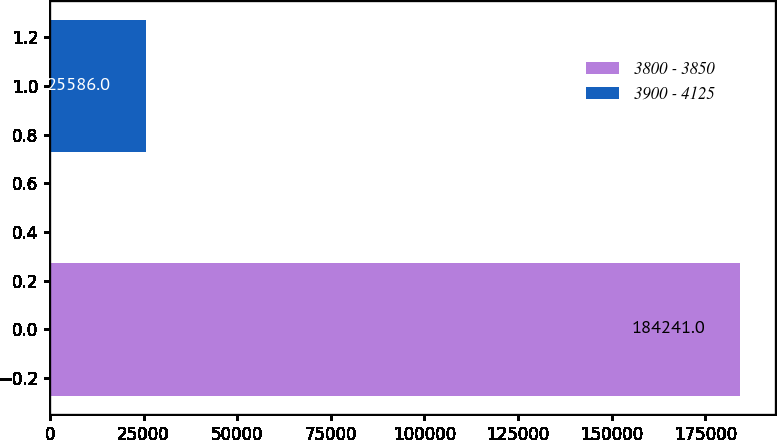Convert chart to OTSL. <chart><loc_0><loc_0><loc_500><loc_500><bar_chart><fcel>3800 - 3850<fcel>3900 - 4125<nl><fcel>184241<fcel>25586<nl></chart> 